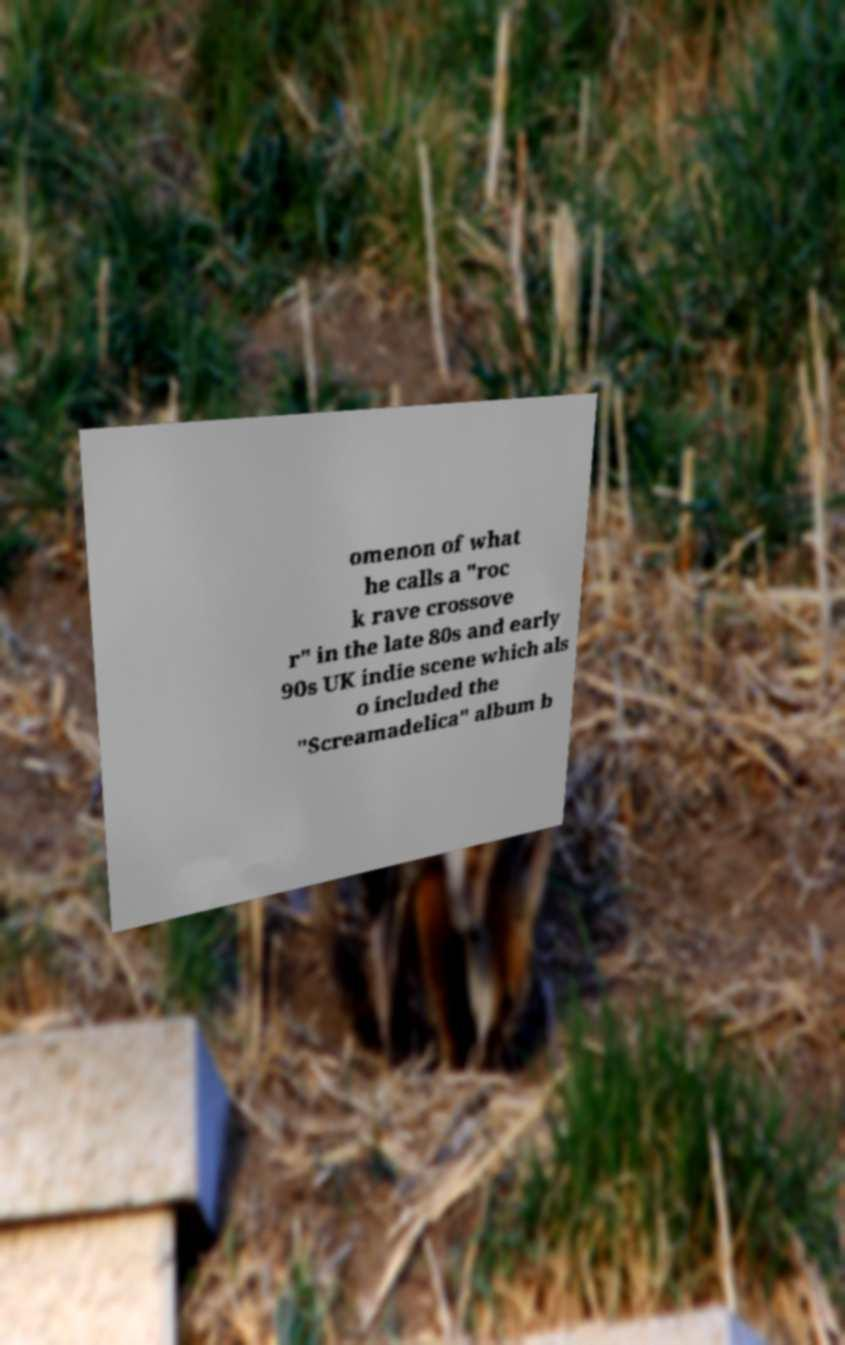Can you accurately transcribe the text from the provided image for me? omenon of what he calls a "roc k rave crossove r" in the late 80s and early 90s UK indie scene which als o included the "Screamadelica" album b 